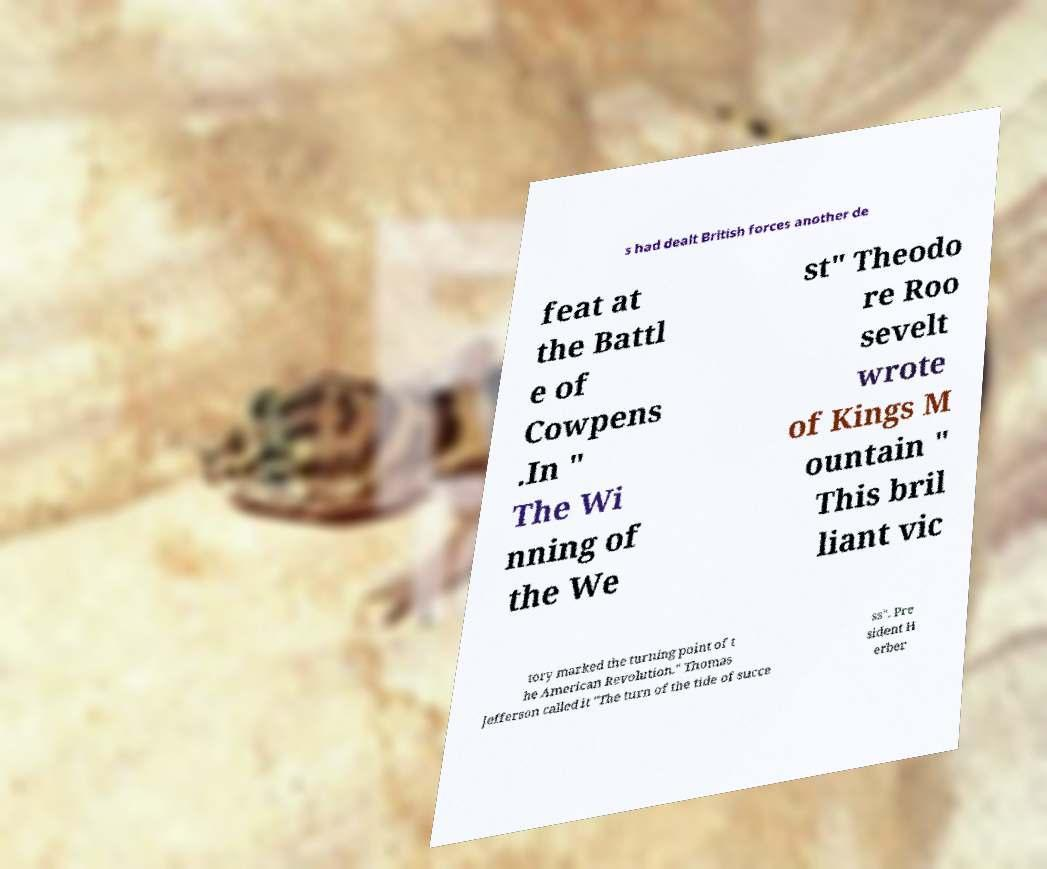For documentation purposes, I need the text within this image transcribed. Could you provide that? s had dealt British forces another de feat at the Battl e of Cowpens .In " The Wi nning of the We st" Theodo re Roo sevelt wrote of Kings M ountain " This bril liant vic tory marked the turning point of t he American Revolution." Thomas Jefferson called it "The turn of the tide of succe ss". Pre sident H erber 